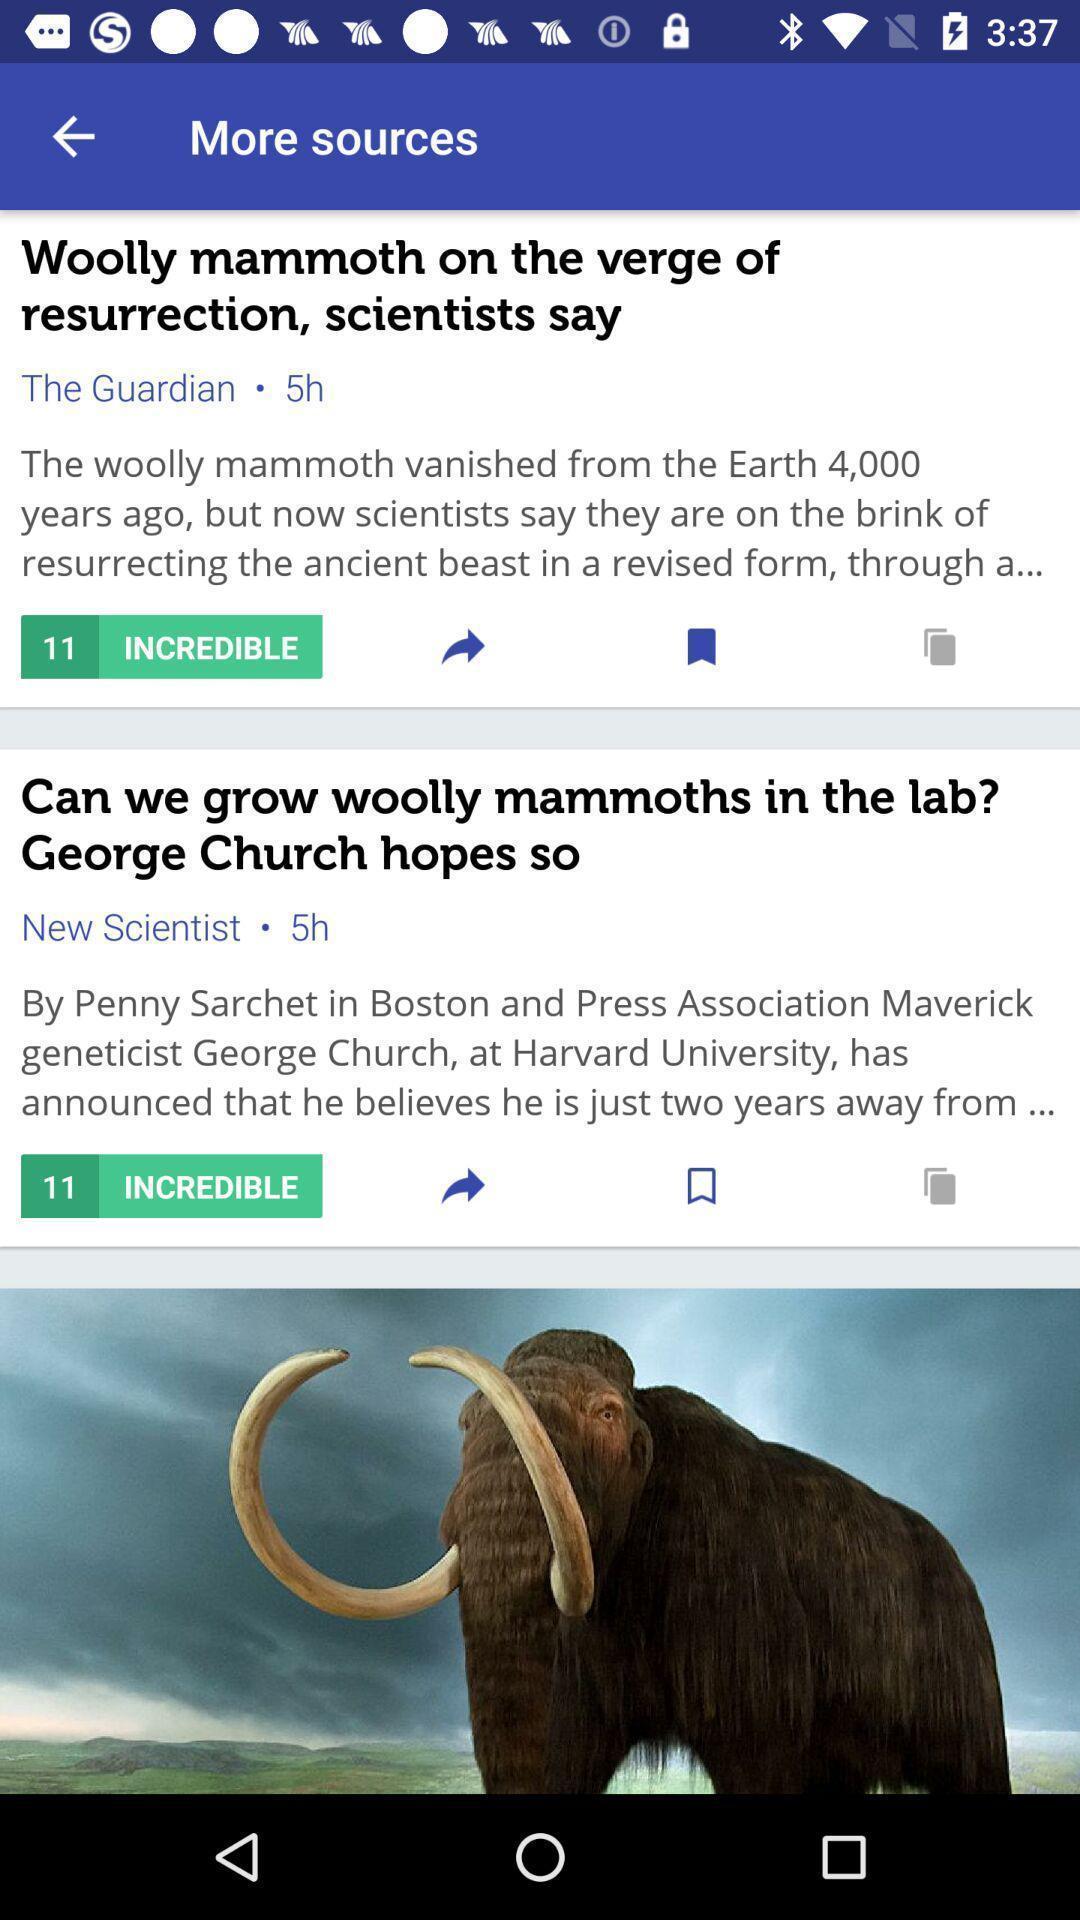Provide a detailed account of this screenshot. Screen displaying list of articles. 